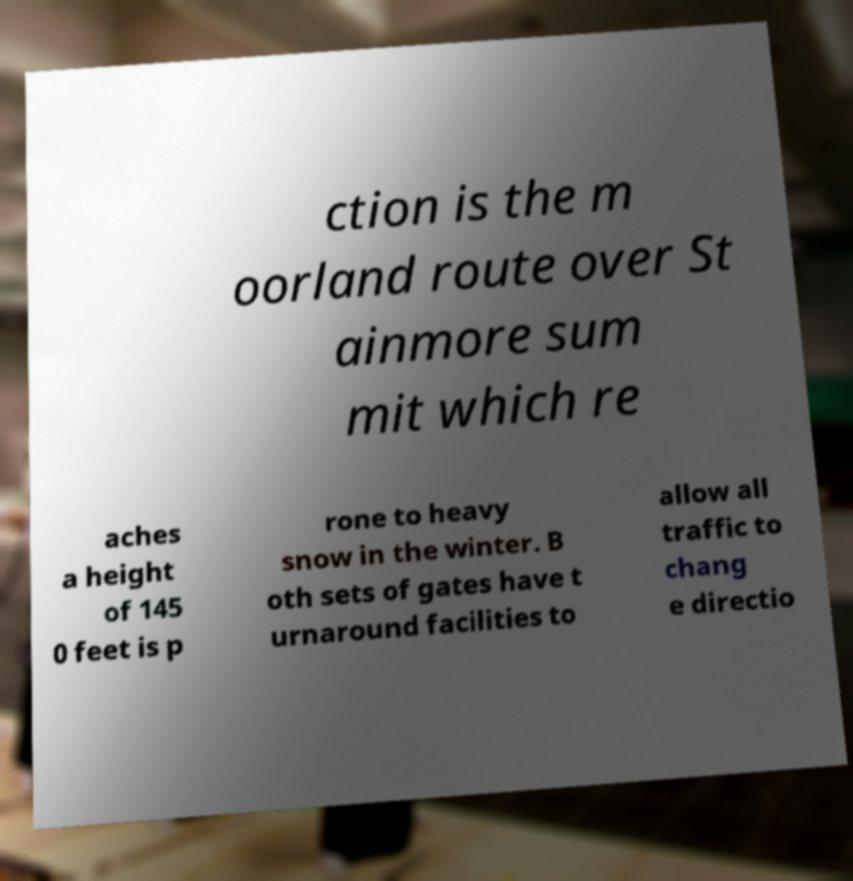Can you accurately transcribe the text from the provided image for me? ction is the m oorland route over St ainmore sum mit which re aches a height of 145 0 feet is p rone to heavy snow in the winter. B oth sets of gates have t urnaround facilities to allow all traffic to chang e directio 